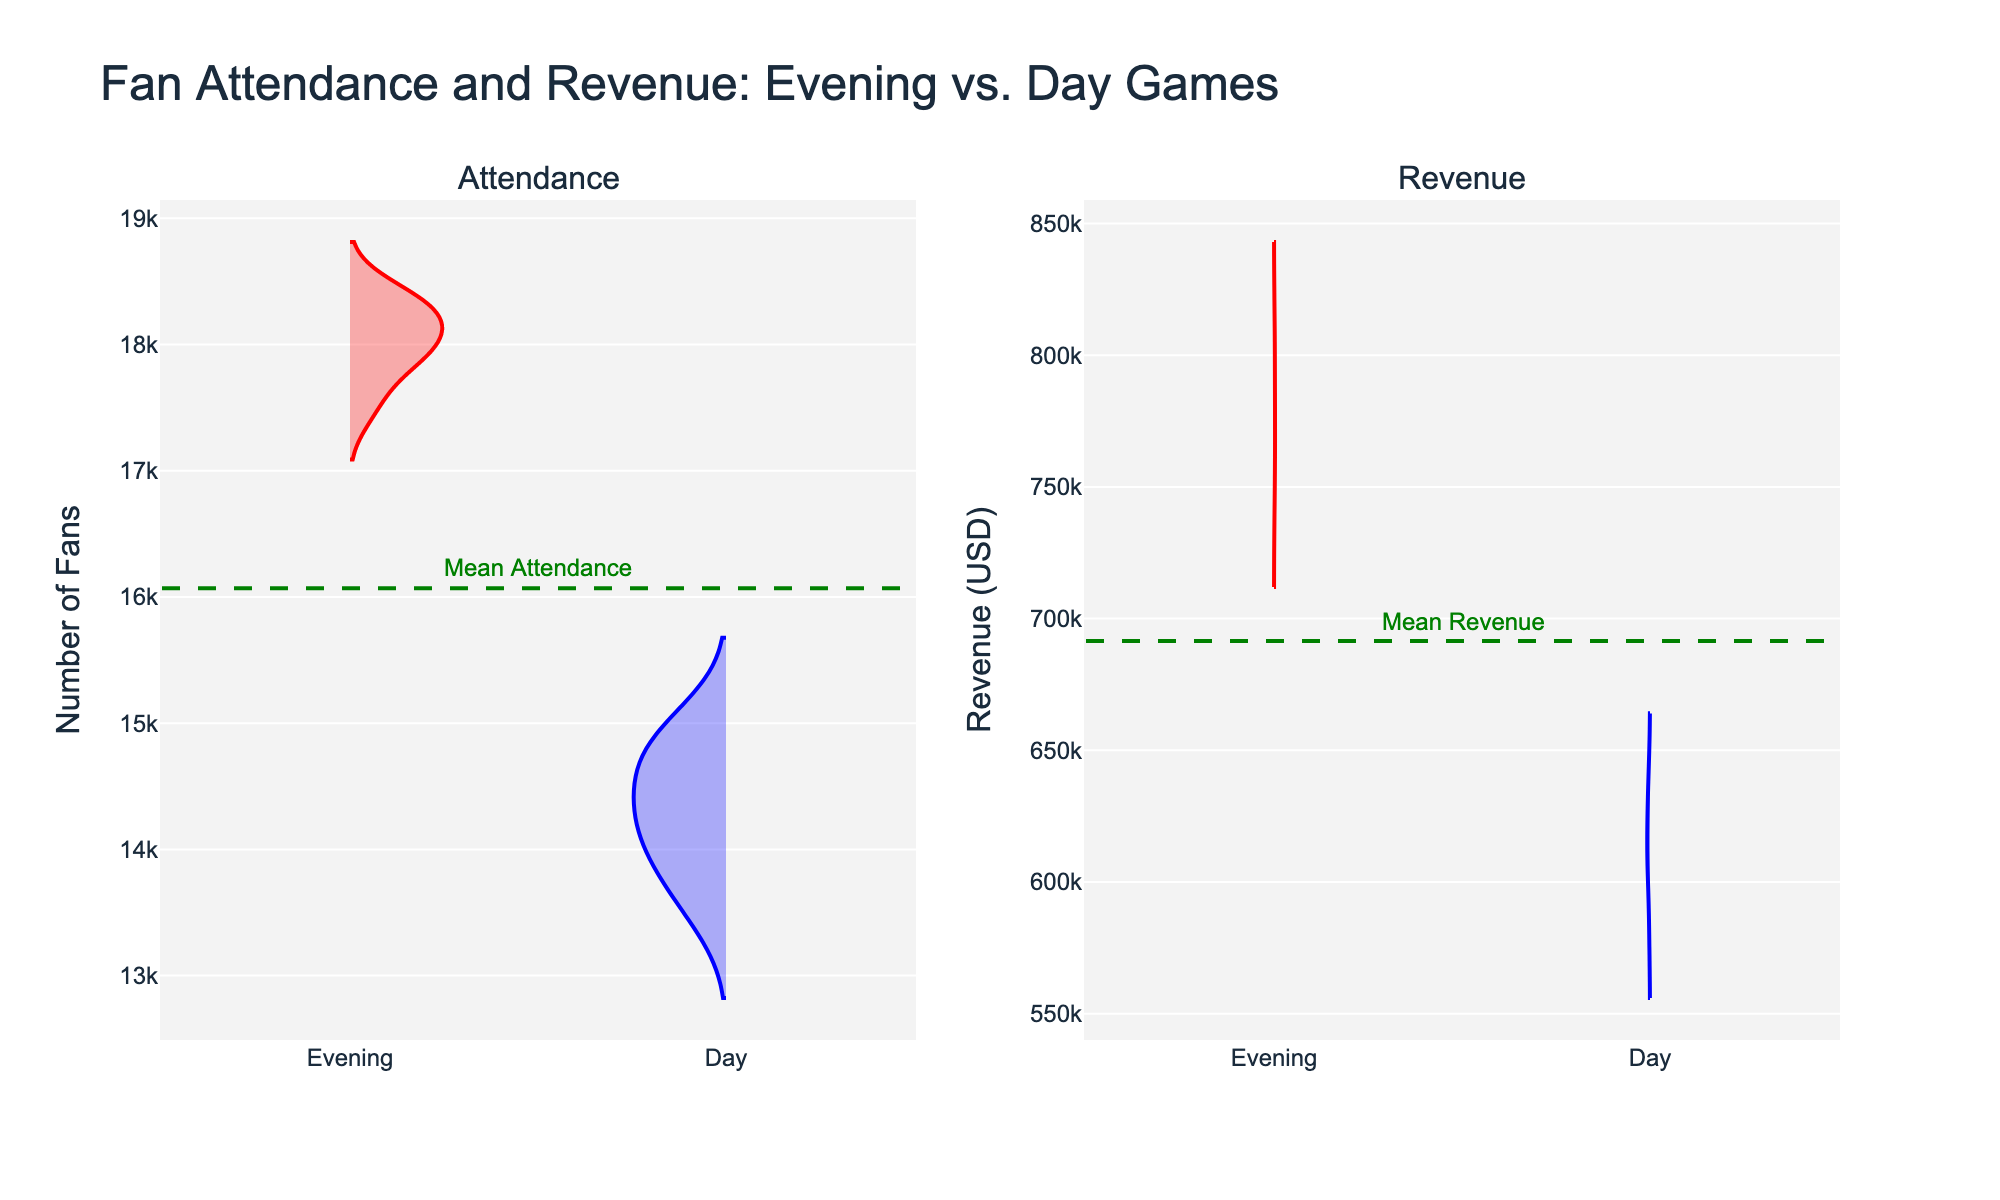What's the title of the plot? The title of the plot is displayed at the top-center of the figure.
Answer: Fan Attendance and Revenue: Evening vs. Day Games What are the shades of colors used for the Evening and Day game types in the plot? The Evening game type uses shades of red, with the violin charts having a red outline and a light red fill. The Day game type uses shades of blue, with the violin charts having a blue outline and a light blue fill.
Answer: Red and Blue What is the mean attendance for both Evening and Day games combined? The mean attendance is marked by a dashed green line on the Attendance subplot. The position of the line, noted in the annotation as "Mean Attendance," gives this value.
Answer: Approximately 16237.5 Which game type generally has a higher revenue? The height and density of the violin plots in the Revenue subplot indicate that Evening games generally have higher revenue compared to Day games. This is evident through the higher position and larger width of the Evening game’s violin compared to the Day game’s.
Answer: Evening Is there a notable difference in attendance between Evening and Day games? Comparing the attendance violins, the Evening games' attendance plots are generally positioned higher and have a broader spread compared to the Day games' attendance violins, indicating higher and more variable attendance.
Answer: Yes How many Evening game data points are plotted in the Revenue subplot? By counting the vertical spread in the shaded red area of the Revenue subplot, one can see that there are 8 data points for Evening games.
Answer: 8 Which game type tends to have a more consistent attendance rate? The width of the violin plots indicates the spread of the data. The Day games have a narrower violin plot in the Attendance subplot, indicating a more consistent (less variable) attendance rate compared to Evening games.
Answer: Day Which game type has the highest single recorded revenue? The highest violin plot for revenue corresponds to the Evening game type, as the top part of the Evening violin plot is positioned higher than any other part of the Day violin plot.
Answer: Evening What is the approximate value of the mean revenue? The mean revenue is represented by the green dashed line in the Revenue subplot and is labeled with an annotation stating "Mean Revenue."
Answer: Approximately 672500 How does attendance compare between Evening and Day games at their respective median points? The median can be approximated by the center value of the violin plot's distribution. The Evening game’s median attendance is higher than the median attendance for Day games, as the central part of the Evening game’s attendance violin plot lies above the Day game’s median point.
Answer: Evening has a higher median attendance 